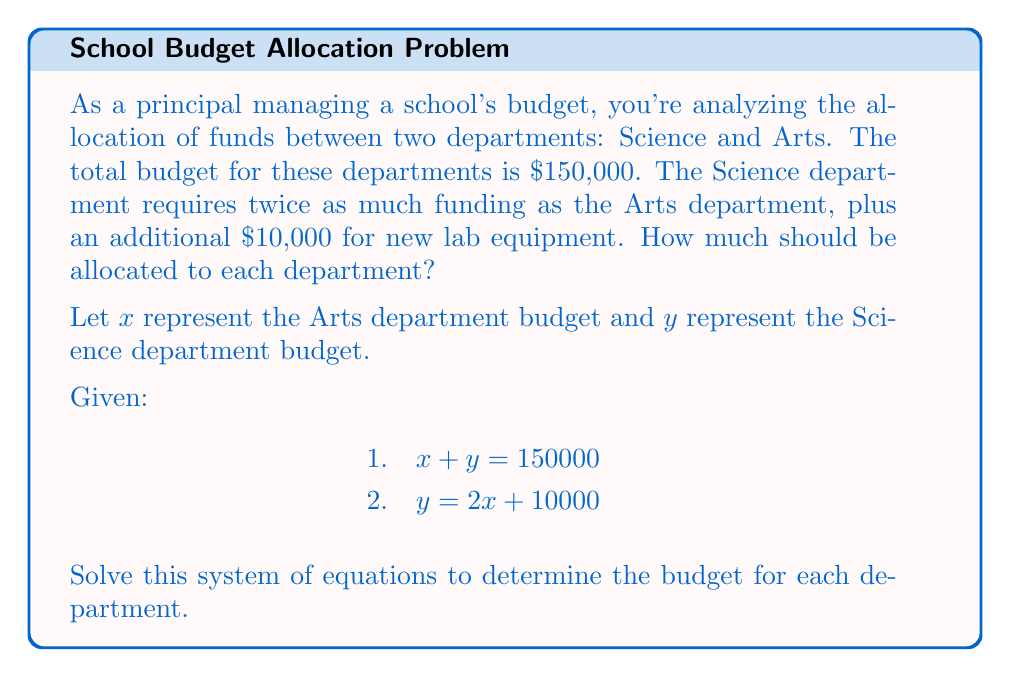What is the answer to this math problem? Let's solve this system of equations step by step:

1) We have two equations:
   $x + y = 150000$ (Equation 1)
   $y = 2x + 10000$ (Equation 2)

2) Substitute Equation 2 into Equation 1:
   $x + (2x + 10000) = 150000$

3) Simplify:
   $3x + 10000 = 150000$

4) Subtract 10000 from both sides:
   $3x = 140000$

5) Divide both sides by 3:
   $x = \frac{140000}{3} \approx 46666.67$

6) Round to the nearest dollar:
   $x = 46667$ (Arts department budget)

7) To find y, substitute x into Equation 2:
   $y = 2(46667) + 10000 = 103334$

8) Check: $46667 + 103334 = 150001$ (difference due to rounding)

Therefore, the Arts department should be allocated $46,667 and the Science department $103,334.
Answer: Arts: $46,667; Science: $103,334 